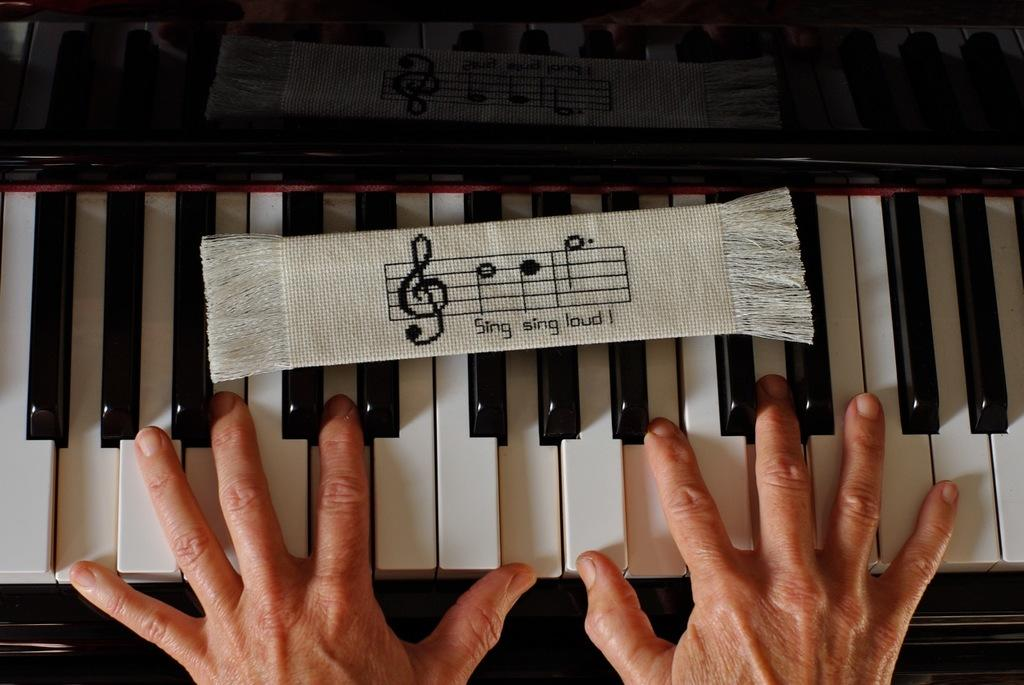What part of the human body is visible in the image? There is a human hand in the image. What musical instrument is present in the image? There is a piano in the image. Where is the seashore located in the image? There is no seashore present in the image; it features a human hand and a piano. What type of paste is being used to play the piano in the image? There is no paste being used to play the piano in the image; it is a musical instrument that is played by pressing keys. 